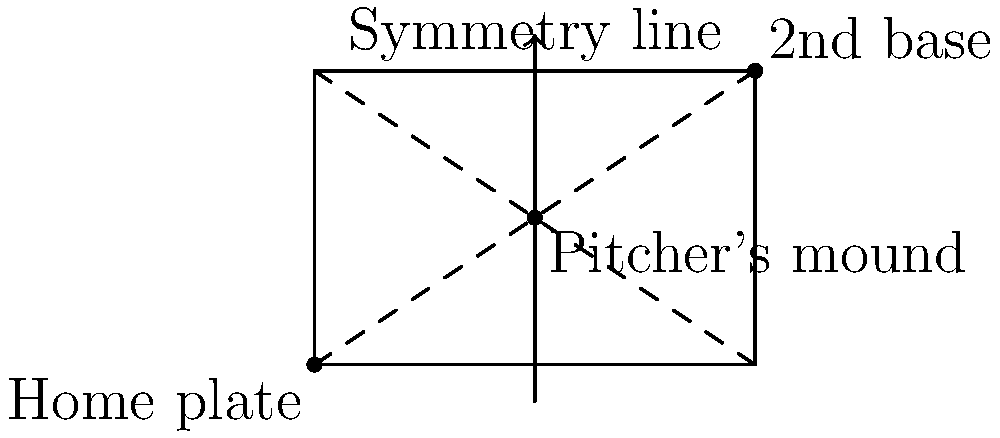In the diagram of a baseball diamond above, which type of symmetry is demonstrated by the dashed lines, and how many times can the field be rotated to match its original position? Let's analyze the symmetry of the baseball diamond step-by-step:

1. The dashed lines in the diagram represent lines of reflection symmetry. There are two such lines:
   - One from home plate to second base
   - One from first base to third base

2. These lines of symmetry divide the field into four equal parts, demonstrating reflectional symmetry.

3. Rotational symmetry is also present in this design. To determine how many times the field can be rotated to match its original position, we need to consider full rotations (360°):

   - A 90° rotation (1/4 of a full rotation) brings the field back to its original position
   - This can be done 4 times to complete a full 360° rotation

4. Therefore, the field has 4-fold rotational symmetry, meaning it can be rotated 4 times (including the original position) to match its starting orientation.

This symmetrical design ensures fairness in gameplay, as the field looks the same from all bases and provides equal opportunities for both left-handed and right-handed players.
Answer: Reflectional symmetry; 4 rotations 